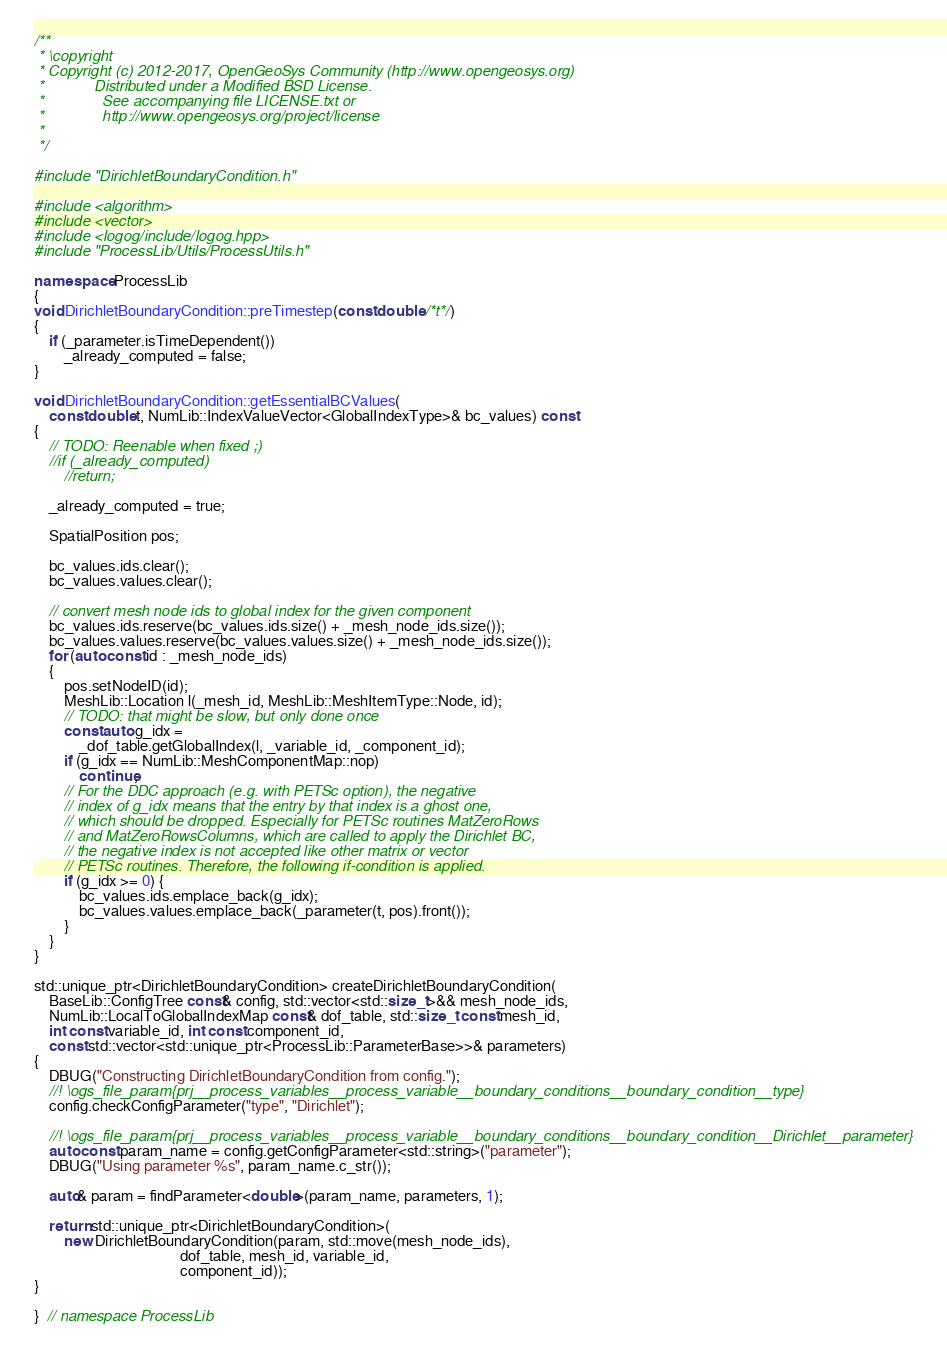Convert code to text. <code><loc_0><loc_0><loc_500><loc_500><_C++_>/**
 * \copyright
 * Copyright (c) 2012-2017, OpenGeoSys Community (http://www.opengeosys.org)
 *            Distributed under a Modified BSD License.
 *              See accompanying file LICENSE.txt or
 *              http://www.opengeosys.org/project/license
 *
 */

#include "DirichletBoundaryCondition.h"

#include <algorithm>
#include <vector>
#include <logog/include/logog.hpp>
#include "ProcessLib/Utils/ProcessUtils.h"

namespace ProcessLib
{
void DirichletBoundaryCondition::preTimestep(const double /*t*/)
{
    if (_parameter.isTimeDependent())
        _already_computed = false;
}

void DirichletBoundaryCondition::getEssentialBCValues(
    const double t, NumLib::IndexValueVector<GlobalIndexType>& bc_values) const
{
    // TODO: Reenable when fixed ;)
    //if (_already_computed)
        //return;

    _already_computed = true;

    SpatialPosition pos;

    bc_values.ids.clear();
    bc_values.values.clear();

    // convert mesh node ids to global index for the given component
    bc_values.ids.reserve(bc_values.ids.size() + _mesh_node_ids.size());
    bc_values.values.reserve(bc_values.values.size() + _mesh_node_ids.size());
    for (auto const id : _mesh_node_ids)
    {
        pos.setNodeID(id);
        MeshLib::Location l(_mesh_id, MeshLib::MeshItemType::Node, id);
        // TODO: that might be slow, but only done once
        const auto g_idx =
            _dof_table.getGlobalIndex(l, _variable_id, _component_id);
        if (g_idx == NumLib::MeshComponentMap::nop)
            continue;
        // For the DDC approach (e.g. with PETSc option), the negative
        // index of g_idx means that the entry by that index is a ghost one,
        // which should be dropped. Especially for PETSc routines MatZeroRows
        // and MatZeroRowsColumns, which are called to apply the Dirichlet BC,
        // the negative index is not accepted like other matrix or vector
        // PETSc routines. Therefore, the following if-condition is applied.
        if (g_idx >= 0) {
            bc_values.ids.emplace_back(g_idx);
            bc_values.values.emplace_back(_parameter(t, pos).front());
        }
    }
}

std::unique_ptr<DirichletBoundaryCondition> createDirichletBoundaryCondition(
    BaseLib::ConfigTree const& config, std::vector<std::size_t>&& mesh_node_ids,
    NumLib::LocalToGlobalIndexMap const& dof_table, std::size_t const mesh_id,
    int const variable_id, int const component_id,
    const std::vector<std::unique_ptr<ProcessLib::ParameterBase>>& parameters)
{
    DBUG("Constructing DirichletBoundaryCondition from config.");
    //! \ogs_file_param{prj__process_variables__process_variable__boundary_conditions__boundary_condition__type}
    config.checkConfigParameter("type", "Dirichlet");

    //! \ogs_file_param{prj__process_variables__process_variable__boundary_conditions__boundary_condition__Dirichlet__parameter}
    auto const param_name = config.getConfigParameter<std::string>("parameter");
    DBUG("Using parameter %s", param_name.c_str());

    auto& param = findParameter<double>(param_name, parameters, 1);

    return std::unique_ptr<DirichletBoundaryCondition>(
        new DirichletBoundaryCondition(param, std::move(mesh_node_ids),
                                       dof_table, mesh_id, variable_id,
                                       component_id));
}

}  // namespace ProcessLib
</code> 